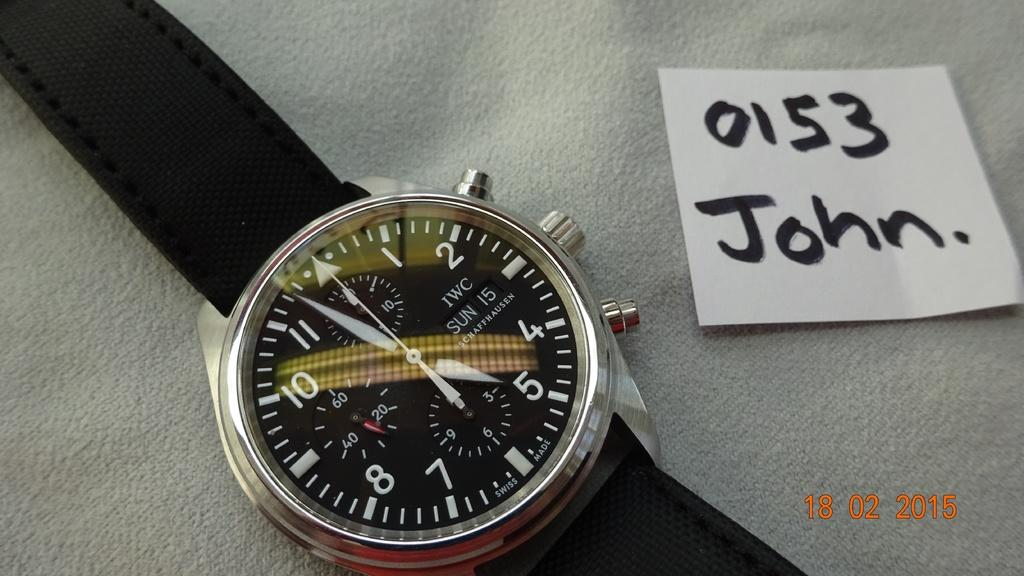<image>
Provide a brief description of the given image. an IWC watch says it is nearly five to five next to a post it note saying 0153 John. 